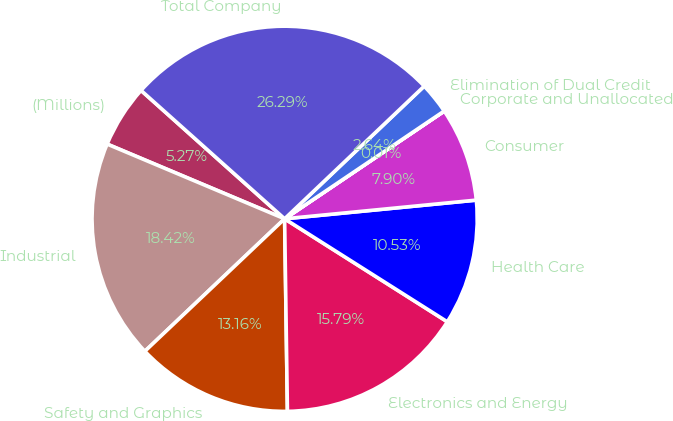Convert chart. <chart><loc_0><loc_0><loc_500><loc_500><pie_chart><fcel>(Millions)<fcel>Industrial<fcel>Safety and Graphics<fcel>Electronics and Energy<fcel>Health Care<fcel>Consumer<fcel>Corporate and Unallocated<fcel>Elimination of Dual Credit<fcel>Total Company<nl><fcel>5.27%<fcel>18.42%<fcel>13.16%<fcel>15.79%<fcel>10.53%<fcel>7.9%<fcel>0.01%<fcel>2.64%<fcel>26.3%<nl></chart> 